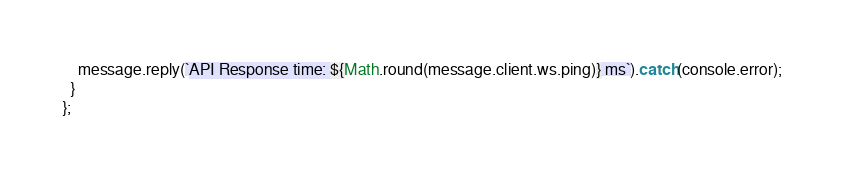Convert code to text. <code><loc_0><loc_0><loc_500><loc_500><_JavaScript_>    message.reply(`API Response time: ${Math.round(message.client.ws.ping)} ms`).catch(console.error);
  }
};
</code> 